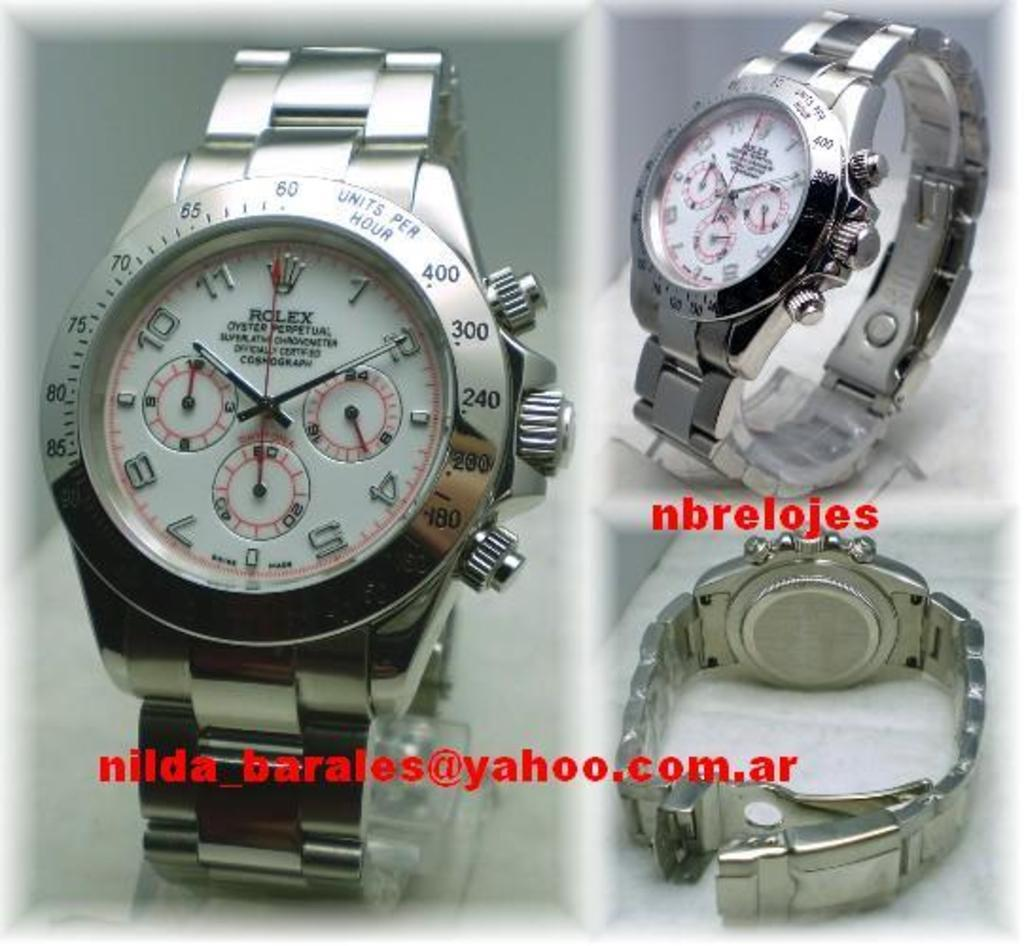<image>
Present a compact description of the photo's key features. A silver Rolex Oyster Perpetual wristwatch with a white face. 